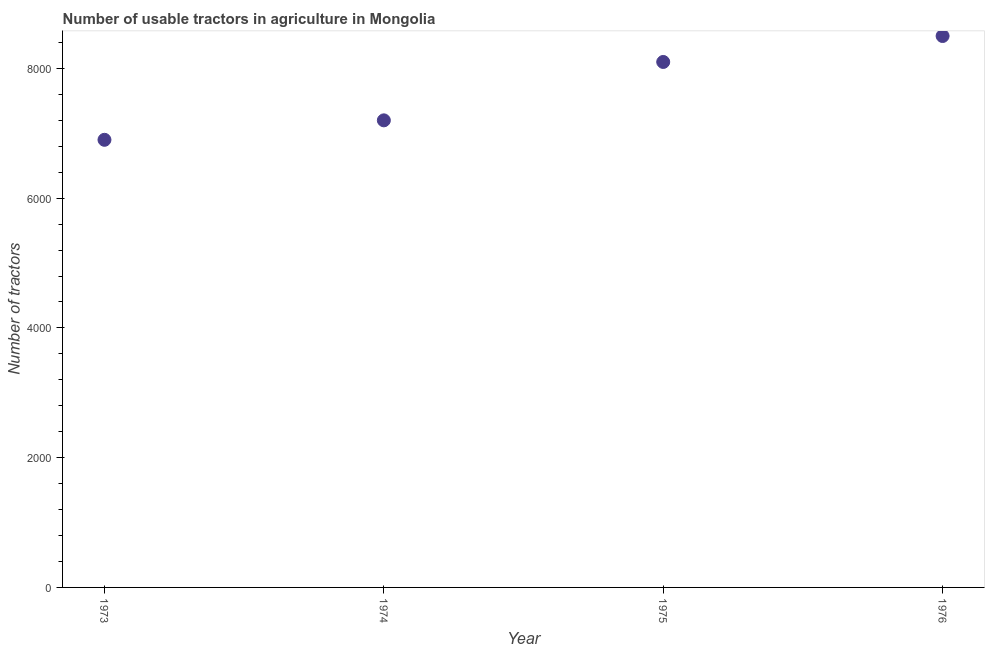What is the number of tractors in 1975?
Your answer should be compact. 8100. Across all years, what is the maximum number of tractors?
Provide a succinct answer. 8500. Across all years, what is the minimum number of tractors?
Your answer should be compact. 6900. In which year was the number of tractors maximum?
Give a very brief answer. 1976. In which year was the number of tractors minimum?
Offer a very short reply. 1973. What is the sum of the number of tractors?
Make the answer very short. 3.07e+04. What is the difference between the number of tractors in 1974 and 1975?
Offer a very short reply. -900. What is the average number of tractors per year?
Make the answer very short. 7675. What is the median number of tractors?
Give a very brief answer. 7650. In how many years, is the number of tractors greater than 4000 ?
Your answer should be very brief. 4. What is the ratio of the number of tractors in 1973 to that in 1976?
Offer a very short reply. 0.81. What is the difference between the highest and the lowest number of tractors?
Provide a succinct answer. 1600. Does the number of tractors monotonically increase over the years?
Make the answer very short. Yes. How many dotlines are there?
Offer a terse response. 1. What is the difference between two consecutive major ticks on the Y-axis?
Offer a very short reply. 2000. Are the values on the major ticks of Y-axis written in scientific E-notation?
Your response must be concise. No. Does the graph contain any zero values?
Offer a terse response. No. What is the title of the graph?
Ensure brevity in your answer.  Number of usable tractors in agriculture in Mongolia. What is the label or title of the X-axis?
Your answer should be very brief. Year. What is the label or title of the Y-axis?
Your response must be concise. Number of tractors. What is the Number of tractors in 1973?
Your response must be concise. 6900. What is the Number of tractors in 1974?
Your answer should be very brief. 7200. What is the Number of tractors in 1975?
Offer a very short reply. 8100. What is the Number of tractors in 1976?
Give a very brief answer. 8500. What is the difference between the Number of tractors in 1973 and 1974?
Make the answer very short. -300. What is the difference between the Number of tractors in 1973 and 1975?
Your answer should be compact. -1200. What is the difference between the Number of tractors in 1973 and 1976?
Provide a short and direct response. -1600. What is the difference between the Number of tractors in 1974 and 1975?
Ensure brevity in your answer.  -900. What is the difference between the Number of tractors in 1974 and 1976?
Your response must be concise. -1300. What is the difference between the Number of tractors in 1975 and 1976?
Keep it short and to the point. -400. What is the ratio of the Number of tractors in 1973 to that in 1974?
Your response must be concise. 0.96. What is the ratio of the Number of tractors in 1973 to that in 1975?
Provide a short and direct response. 0.85. What is the ratio of the Number of tractors in 1973 to that in 1976?
Keep it short and to the point. 0.81. What is the ratio of the Number of tractors in 1974 to that in 1975?
Offer a very short reply. 0.89. What is the ratio of the Number of tractors in 1974 to that in 1976?
Ensure brevity in your answer.  0.85. What is the ratio of the Number of tractors in 1975 to that in 1976?
Make the answer very short. 0.95. 